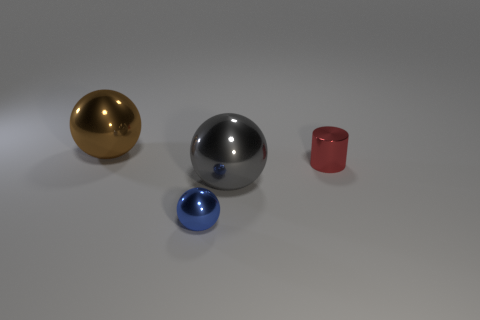Add 3 small blue shiny balls. How many objects exist? 7 Subtract all spheres. How many objects are left? 1 Subtract all brown spheres. How many spheres are left? 2 Subtract all small blue metal spheres. How many spheres are left? 2 Subtract 3 spheres. How many spheres are left? 0 Subtract all gray cylinders. How many blue spheres are left? 1 Add 3 cylinders. How many cylinders are left? 4 Add 4 brown metallic spheres. How many brown metallic spheres exist? 5 Subtract 0 cyan cubes. How many objects are left? 4 Subtract all blue balls. Subtract all cyan cylinders. How many balls are left? 2 